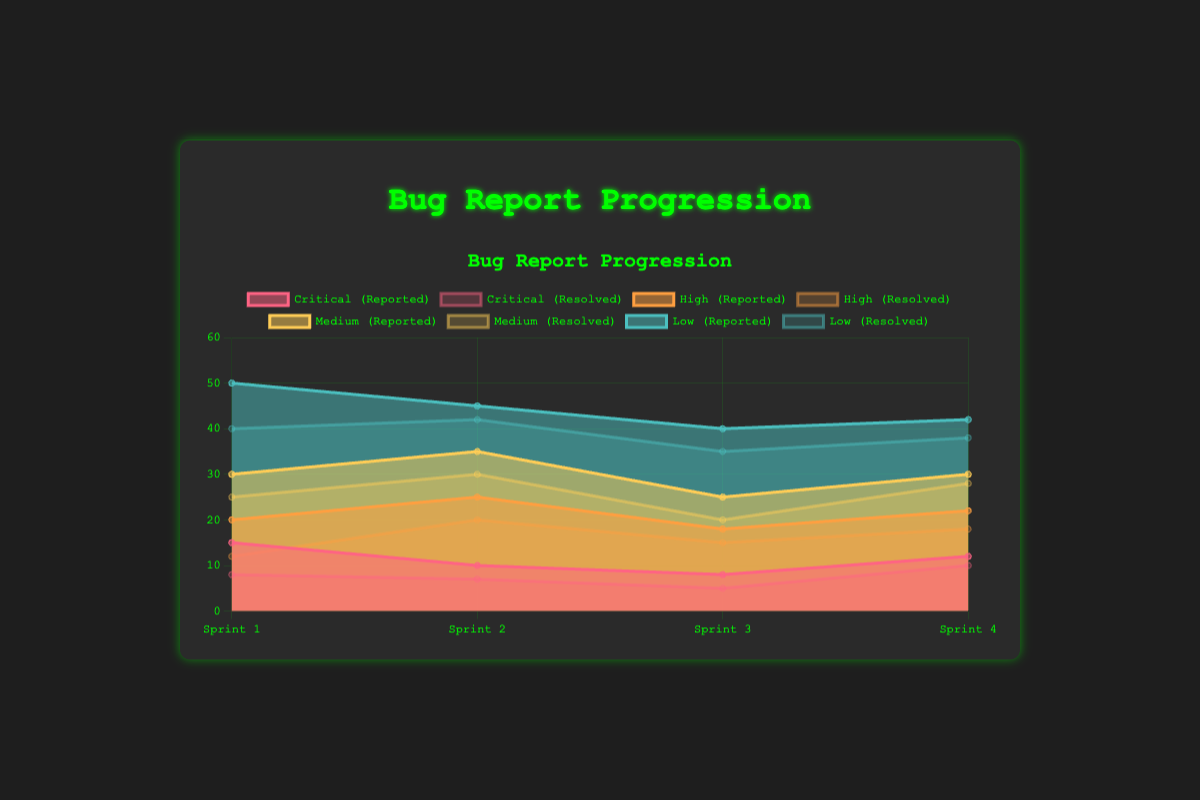What is the title of the chart? The title of the chart is written at the top and is textually visible. The title indicates what the chart is depicting.
Answer: Bug Report Progression How many development cycles are depicted in the chart? The x-axis of the chart represents the development cycles. Count the number of distinct labels on the x-axis to get the total number of cycles.
Answer: 4 What is the trend in the number of reported critical bugs over the development cycles? Look at the data points corresponding to 'Critical (Reported)' in each cycle and observe the direction of the line connecting these points. The trend is indicated by whether the line goes up, down, or stays level.
Answer: Decreasing Which severity level had the highest number of reported bugs in Sprint 2? Examine the height of the stacked areas for each severity level above the point labeled "Sprint 2" on the x-axis. The highest peak indicates the highest number.
Answer: Low How does the number of resolved medium severity bugs in Sprint 4 compare to those in Sprint 3? Look at the data points corresponding to 'Medium (Resolved)' for Sprint 3 and Sprint 4 and compare their values.
Answer: Sprint 4 has more What is the total number of reported low severity bugs across all cycles? Sum the values from each development cycle for 'Low (Reported)'. Sprint 1: 50, Sprint 2: 45, Sprint 3: 40, Sprint 4: 42. Add these to get the total.
Answer: 177 Between which two sprints did the resolution of high severity bugs improve the most? Calculate the difference in the number of high severity bugs resolved between consecutive sprints and identify the pair with the highest positive difference.
Answer: Sprint 1 to Sprint 2 Which severity level shows the most variation in reported bugs across the four cycles? Calculate the range (maximum minus minimum value) for each severity level's reported bugs across the cycles. The level with the largest range shows the most variation.
Answer: Medium Are there more reported or resolved critical bugs in Sprint 3? Compare the data points for 'Critical (Reported)' and 'Critical (Resolved)' in Sprint 3 specifically.
Answer: Reported What is the overall trend for low severity bug resolution rates across all sprints? Evaluate the points corresponding to 'Low (Resolved)' over the development cycles. Determine whether the overall direction of the line is ascending, descending, or stable.
Answer: Slightly decreasing 